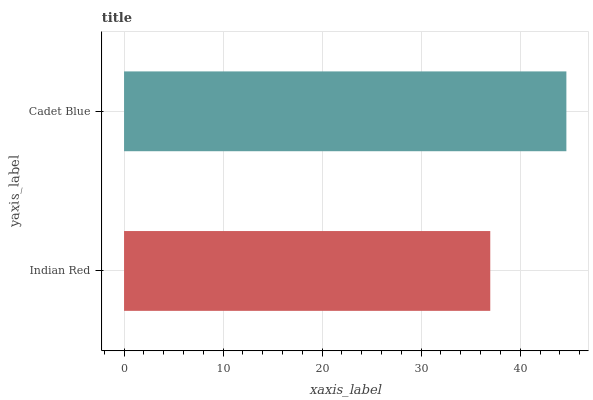Is Indian Red the minimum?
Answer yes or no. Yes. Is Cadet Blue the maximum?
Answer yes or no. Yes. Is Cadet Blue the minimum?
Answer yes or no. No. Is Cadet Blue greater than Indian Red?
Answer yes or no. Yes. Is Indian Red less than Cadet Blue?
Answer yes or no. Yes. Is Indian Red greater than Cadet Blue?
Answer yes or no. No. Is Cadet Blue less than Indian Red?
Answer yes or no. No. Is Cadet Blue the high median?
Answer yes or no. Yes. Is Indian Red the low median?
Answer yes or no. Yes. Is Indian Red the high median?
Answer yes or no. No. Is Cadet Blue the low median?
Answer yes or no. No. 